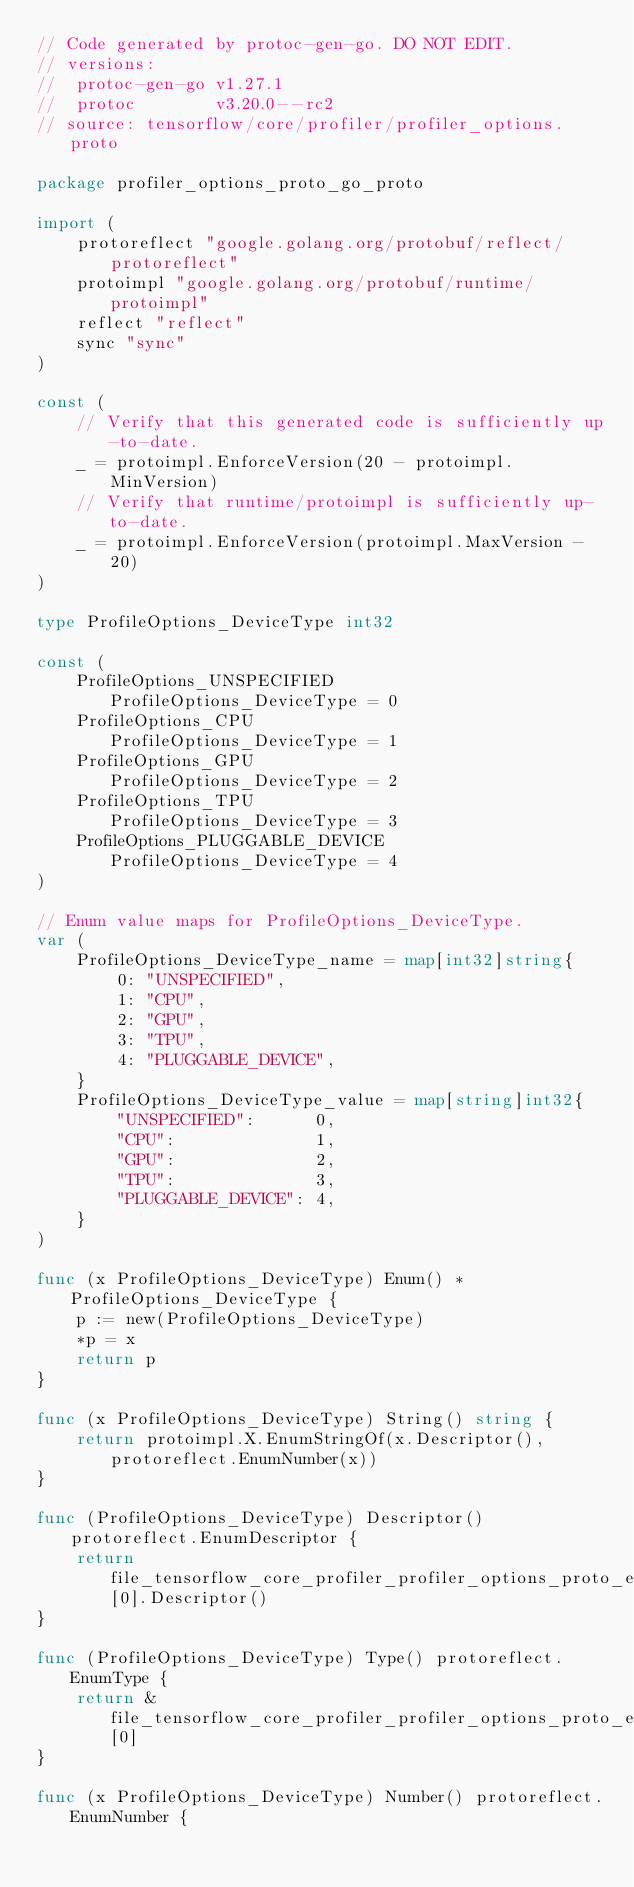Convert code to text. <code><loc_0><loc_0><loc_500><loc_500><_Go_>// Code generated by protoc-gen-go. DO NOT EDIT.
// versions:
// 	protoc-gen-go v1.27.1
// 	protoc        v3.20.0--rc2
// source: tensorflow/core/profiler/profiler_options.proto

package profiler_options_proto_go_proto

import (
	protoreflect "google.golang.org/protobuf/reflect/protoreflect"
	protoimpl "google.golang.org/protobuf/runtime/protoimpl"
	reflect "reflect"
	sync "sync"
)

const (
	// Verify that this generated code is sufficiently up-to-date.
	_ = protoimpl.EnforceVersion(20 - protoimpl.MinVersion)
	// Verify that runtime/protoimpl is sufficiently up-to-date.
	_ = protoimpl.EnforceVersion(protoimpl.MaxVersion - 20)
)

type ProfileOptions_DeviceType int32

const (
	ProfileOptions_UNSPECIFIED      ProfileOptions_DeviceType = 0
	ProfileOptions_CPU              ProfileOptions_DeviceType = 1
	ProfileOptions_GPU              ProfileOptions_DeviceType = 2
	ProfileOptions_TPU              ProfileOptions_DeviceType = 3
	ProfileOptions_PLUGGABLE_DEVICE ProfileOptions_DeviceType = 4
)

// Enum value maps for ProfileOptions_DeviceType.
var (
	ProfileOptions_DeviceType_name = map[int32]string{
		0: "UNSPECIFIED",
		1: "CPU",
		2: "GPU",
		3: "TPU",
		4: "PLUGGABLE_DEVICE",
	}
	ProfileOptions_DeviceType_value = map[string]int32{
		"UNSPECIFIED":      0,
		"CPU":              1,
		"GPU":              2,
		"TPU":              3,
		"PLUGGABLE_DEVICE": 4,
	}
)

func (x ProfileOptions_DeviceType) Enum() *ProfileOptions_DeviceType {
	p := new(ProfileOptions_DeviceType)
	*p = x
	return p
}

func (x ProfileOptions_DeviceType) String() string {
	return protoimpl.X.EnumStringOf(x.Descriptor(), protoreflect.EnumNumber(x))
}

func (ProfileOptions_DeviceType) Descriptor() protoreflect.EnumDescriptor {
	return file_tensorflow_core_profiler_profiler_options_proto_enumTypes[0].Descriptor()
}

func (ProfileOptions_DeviceType) Type() protoreflect.EnumType {
	return &file_tensorflow_core_profiler_profiler_options_proto_enumTypes[0]
}

func (x ProfileOptions_DeviceType) Number() protoreflect.EnumNumber {</code> 